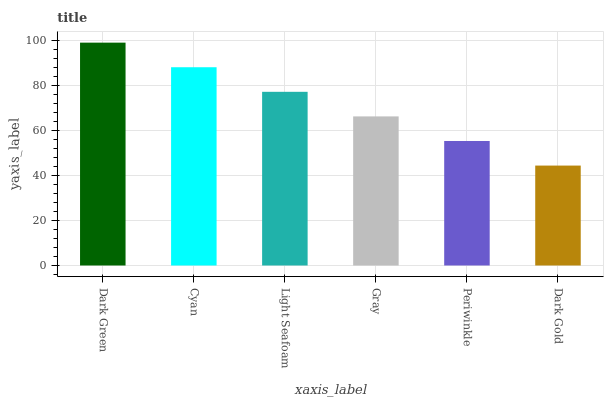Is Dark Gold the minimum?
Answer yes or no. Yes. Is Dark Green the maximum?
Answer yes or no. Yes. Is Cyan the minimum?
Answer yes or no. No. Is Cyan the maximum?
Answer yes or no. No. Is Dark Green greater than Cyan?
Answer yes or no. Yes. Is Cyan less than Dark Green?
Answer yes or no. Yes. Is Cyan greater than Dark Green?
Answer yes or no. No. Is Dark Green less than Cyan?
Answer yes or no. No. Is Light Seafoam the high median?
Answer yes or no. Yes. Is Gray the low median?
Answer yes or no. Yes. Is Periwinkle the high median?
Answer yes or no. No. Is Dark Gold the low median?
Answer yes or no. No. 